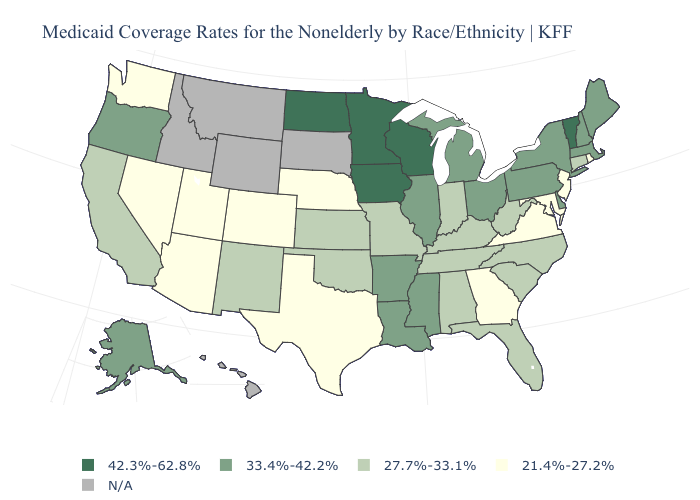What is the value of West Virginia?
Be succinct. 27.7%-33.1%. Name the states that have a value in the range 42.3%-62.8%?
Answer briefly. Iowa, Minnesota, North Dakota, Vermont, Wisconsin. Does Wisconsin have the lowest value in the MidWest?
Quick response, please. No. Name the states that have a value in the range N/A?
Answer briefly. Hawaii, Idaho, Montana, South Dakota, Wyoming. Name the states that have a value in the range N/A?
Answer briefly. Hawaii, Idaho, Montana, South Dakota, Wyoming. Name the states that have a value in the range 27.7%-33.1%?
Answer briefly. Alabama, California, Connecticut, Florida, Indiana, Kansas, Kentucky, Missouri, New Mexico, North Carolina, Oklahoma, South Carolina, Tennessee, West Virginia. Does the first symbol in the legend represent the smallest category?
Concise answer only. No. What is the lowest value in the Northeast?
Concise answer only. 21.4%-27.2%. What is the value of West Virginia?
Short answer required. 27.7%-33.1%. Name the states that have a value in the range 21.4%-27.2%?
Be succinct. Arizona, Colorado, Georgia, Maryland, Nebraska, Nevada, New Jersey, Rhode Island, Texas, Utah, Virginia, Washington. Name the states that have a value in the range 42.3%-62.8%?
Give a very brief answer. Iowa, Minnesota, North Dakota, Vermont, Wisconsin. What is the value of North Carolina?
Be succinct. 27.7%-33.1%. Which states have the highest value in the USA?
Short answer required. Iowa, Minnesota, North Dakota, Vermont, Wisconsin. Among the states that border South Carolina , does Georgia have the lowest value?
Concise answer only. Yes. Name the states that have a value in the range 33.4%-42.2%?
Be succinct. Alaska, Arkansas, Delaware, Illinois, Louisiana, Maine, Massachusetts, Michigan, Mississippi, New Hampshire, New York, Ohio, Oregon, Pennsylvania. 